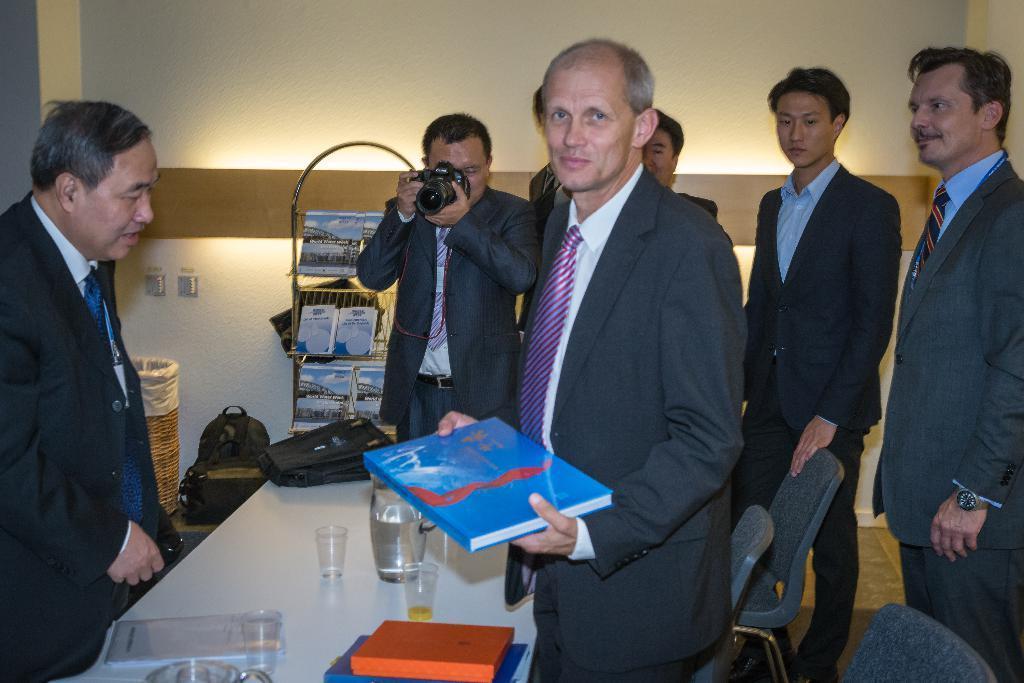In one or two sentences, can you explain what this image depicts? This is an inside view of a room. Here I can see few men wearing suits and standing. The man who is in the middle is holding a book in the hands and looking at the picture. Beside him there is another man holding a camera in the hands. At the bottom there are chairs and a table on which books, glasses, bag and some other objects are placed. In the background there is a rack in which few books are placed. Beside there is a bag placed on the floor and also there is a wooden basket. At the top of the image there is a wall. 